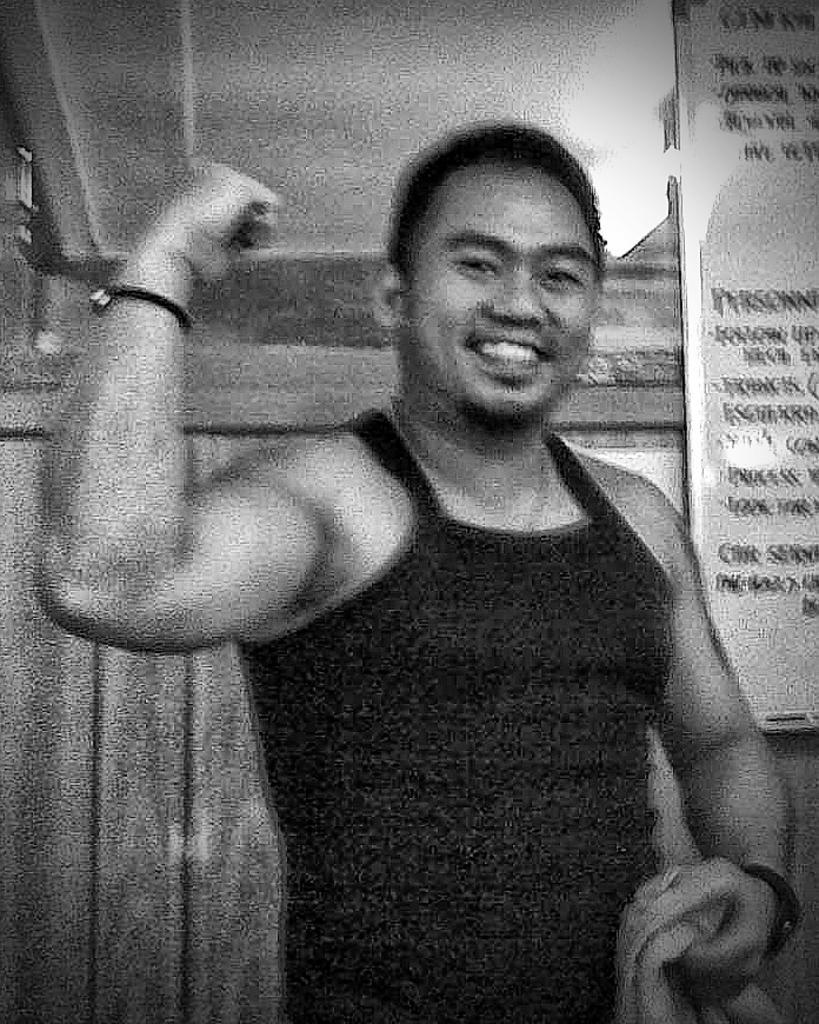In one or two sentences, can you explain what this image depicts? In this image there is a person holding the towel. Behind him there is a display board with some text on it. Beside the display board there is a wall. 